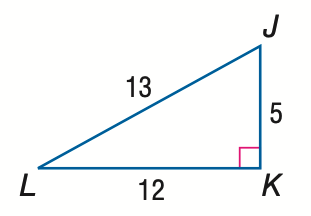Answer the mathemtical geometry problem and directly provide the correct option letter.
Question: Express the ratio of \cos L as a decimal to the nearest hundredth.
Choices: A: 0.38 B: 0.42 C: 0.92 D: 2.40 C 